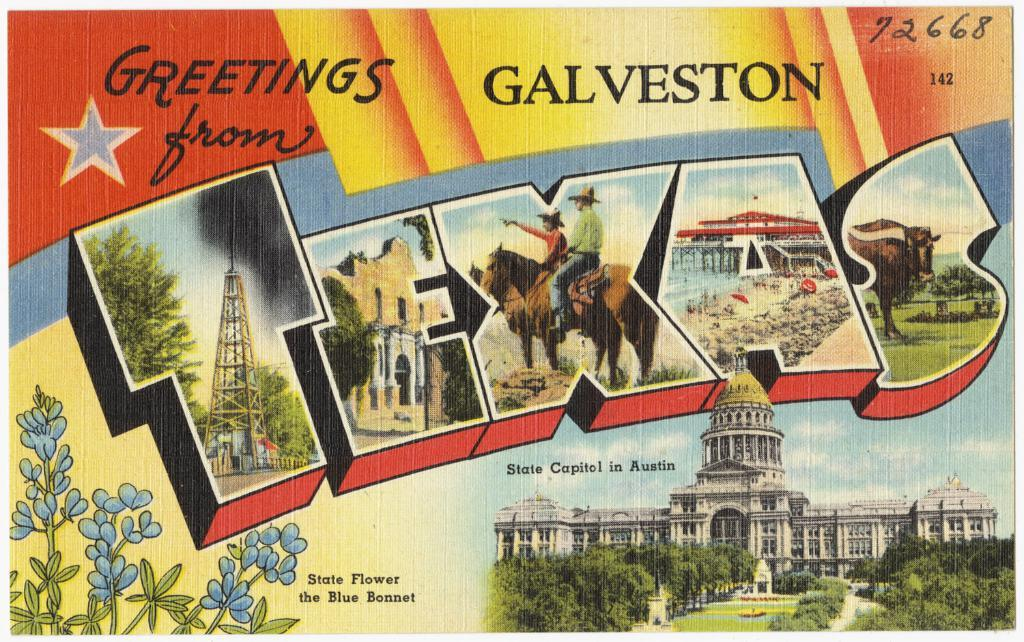<image>
Present a compact description of the photo's key features. A colorful postcard that reads "Greetings from Galveston Texas." 